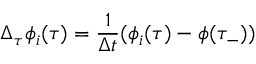<formula> <loc_0><loc_0><loc_500><loc_500>\Delta _ { \tau } \phi _ { i } ( \tau ) = \frac { 1 } { \Delta t } ( \phi _ { i } ( \tau ) - \phi ( \tau _ { - } ) )</formula> 